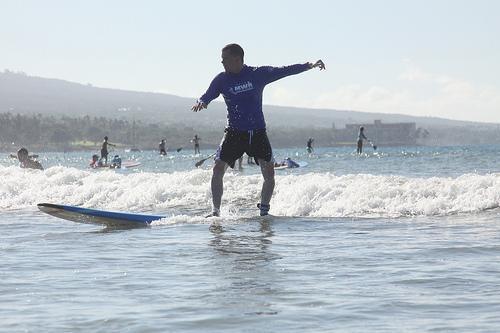How many people are up close?
Give a very brief answer. 1. 